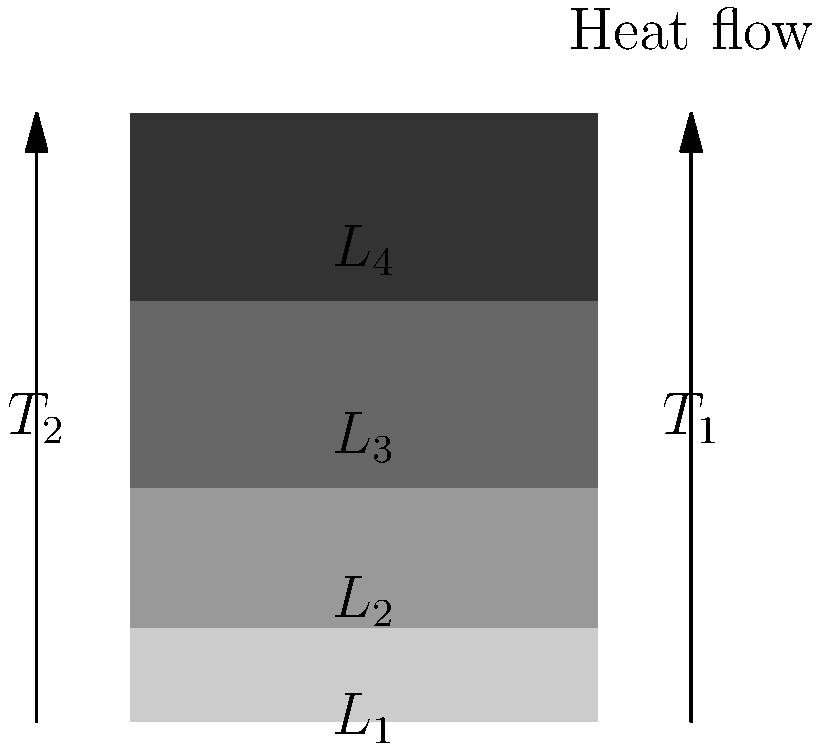As a community leader working on sustainable housing projects, you encounter a wall made of four different materials. The wall has an inner surface temperature ($T_1$) of 30°C and an outer surface temperature ($T_2$) of 5°C. The thicknesses ($L$) and thermal conductivities ($k$) of the layers are as follows:

Layer 1 (innermost): $L_1 = 10$ cm, $k_1 = 0.8$ W/m·K
Layer 2: $L_2 = 15$ cm, $k_2 = 0.5$ W/m·K
Layer 3: $L_3 = 20$ cm, $k_3 = 0.3$ W/m·K
Layer 4 (outermost): $L_4 = 5$ cm, $k_4 = 0.1$ W/m·K

Calculate the rate of heat transfer through 1 square meter of this wall. To solve this problem, we'll use the concept of thermal resistance in series for a multi-layered wall. The steps are as follows:

1) The heat transfer rate $q$ is given by:

   $q = \frac{T_1 - T_2}{R_{total}}$

   where $R_{total}$ is the total thermal resistance of the wall.

2) For a multi-layered wall, $R_{total}$ is the sum of individual layer resistances:

   $R_{total} = R_1 + R_2 + R_3 + R_4$

3) The thermal resistance for each layer is calculated using:

   $R = \frac{L}{k}$

4) Calculate the resistance for each layer:

   $R_1 = \frac{0.10}{0.8} = 0.125$ m²·K/W
   $R_2 = \frac{0.15}{0.5} = 0.300$ m²·K/W
   $R_3 = \frac{0.20}{0.3} = 0.667$ m²·K/W
   $R_4 = \frac{0.05}{0.1} = 0.500$ m²·K/W

5) Sum up the resistances:

   $R_{total} = 0.125 + 0.300 + 0.667 + 0.500 = 1.592$ m²·K/W

6) Calculate the heat transfer rate:

   $q = \frac{T_1 - T_2}{R_{total}} = \frac{30 - 5}{1.592} = 15.70$ W/m²

Therefore, the rate of heat transfer through 1 square meter of this wall is approximately 15.70 W/m².
Answer: 15.70 W/m² 